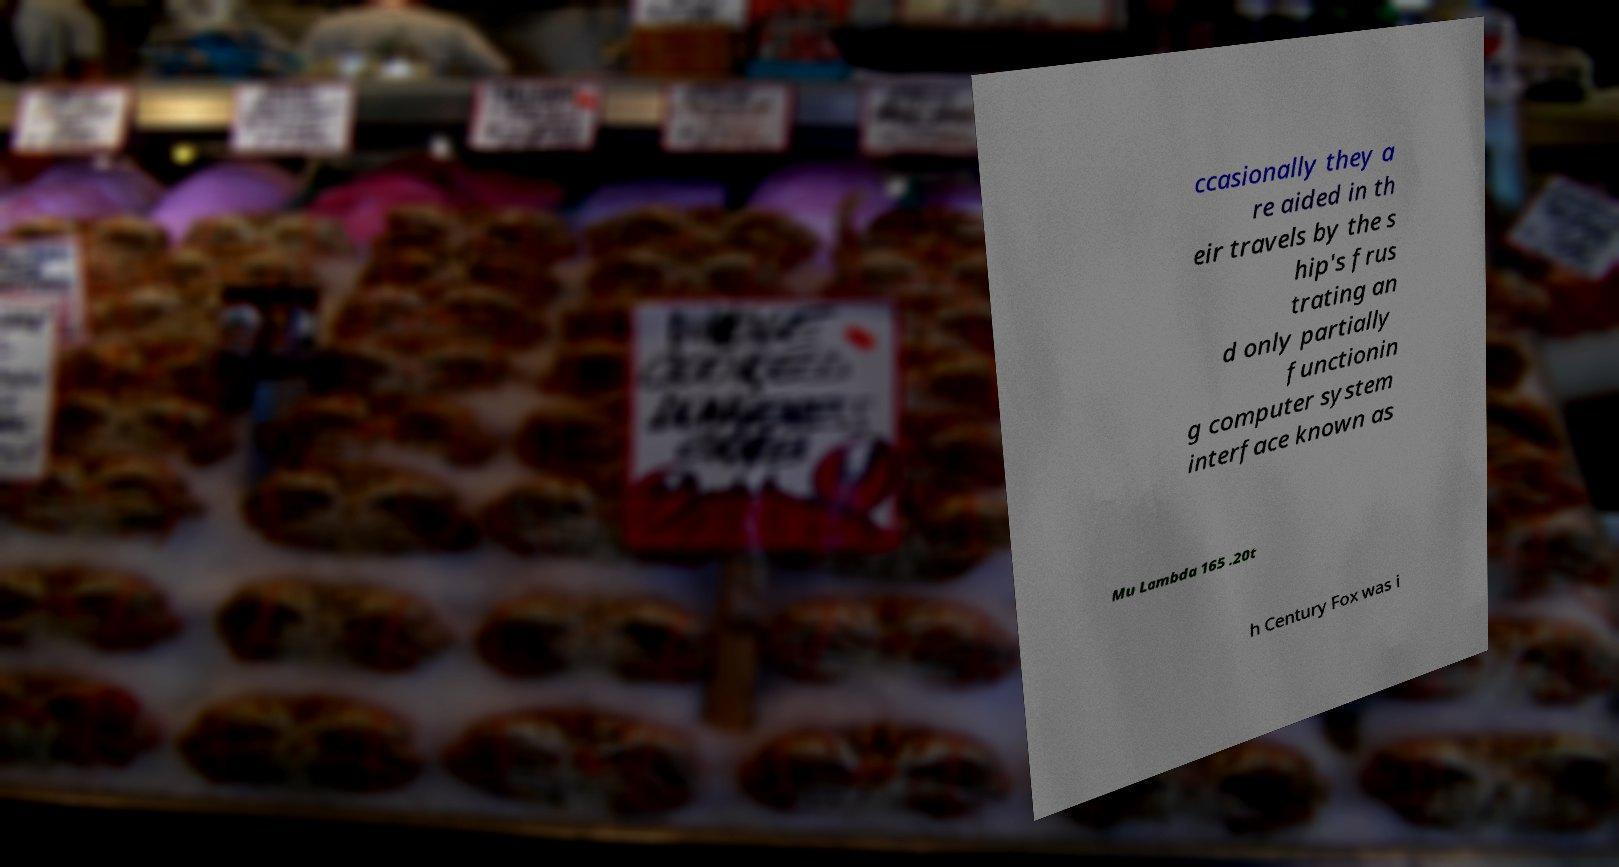Please read and relay the text visible in this image. What does it say? ccasionally they a re aided in th eir travels by the s hip's frus trating an d only partially functionin g computer system interface known as Mu Lambda 165 .20t h Century Fox was i 